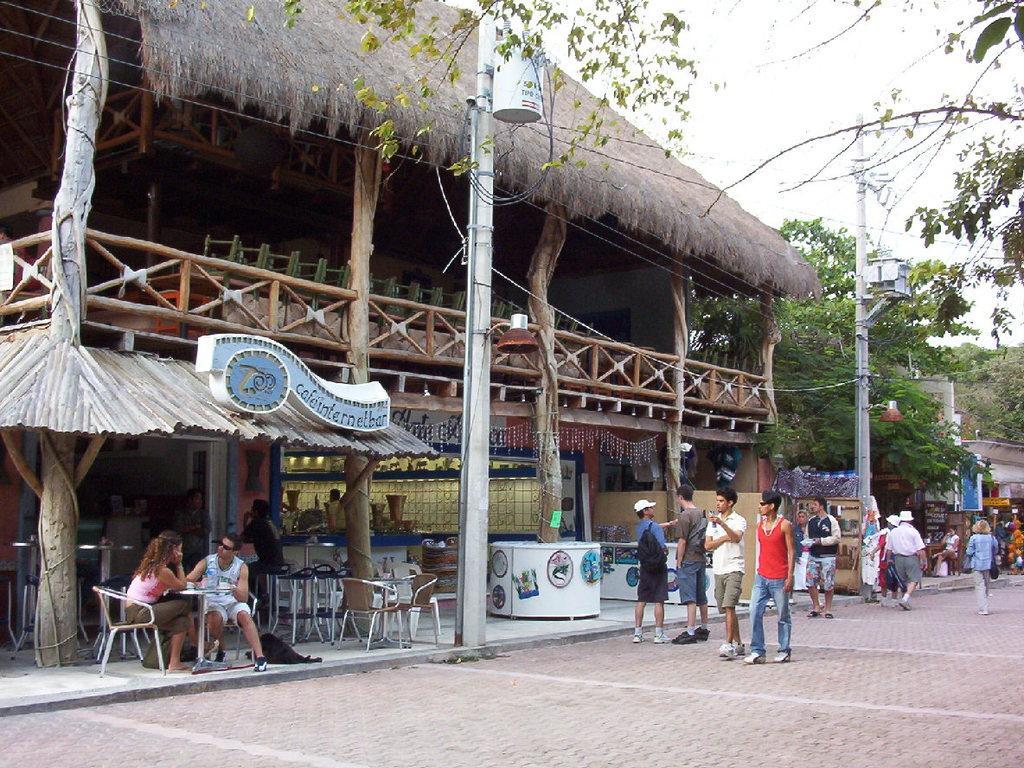In one or two sentences, can you explain what this image depicts? In this image, there are a few people, buildings, poles with wires, trees. We can also see the ground and some boards. We can also see some objects attached to poles. We can see some chairs and tables with objects. We can also see some stories and the sky. 